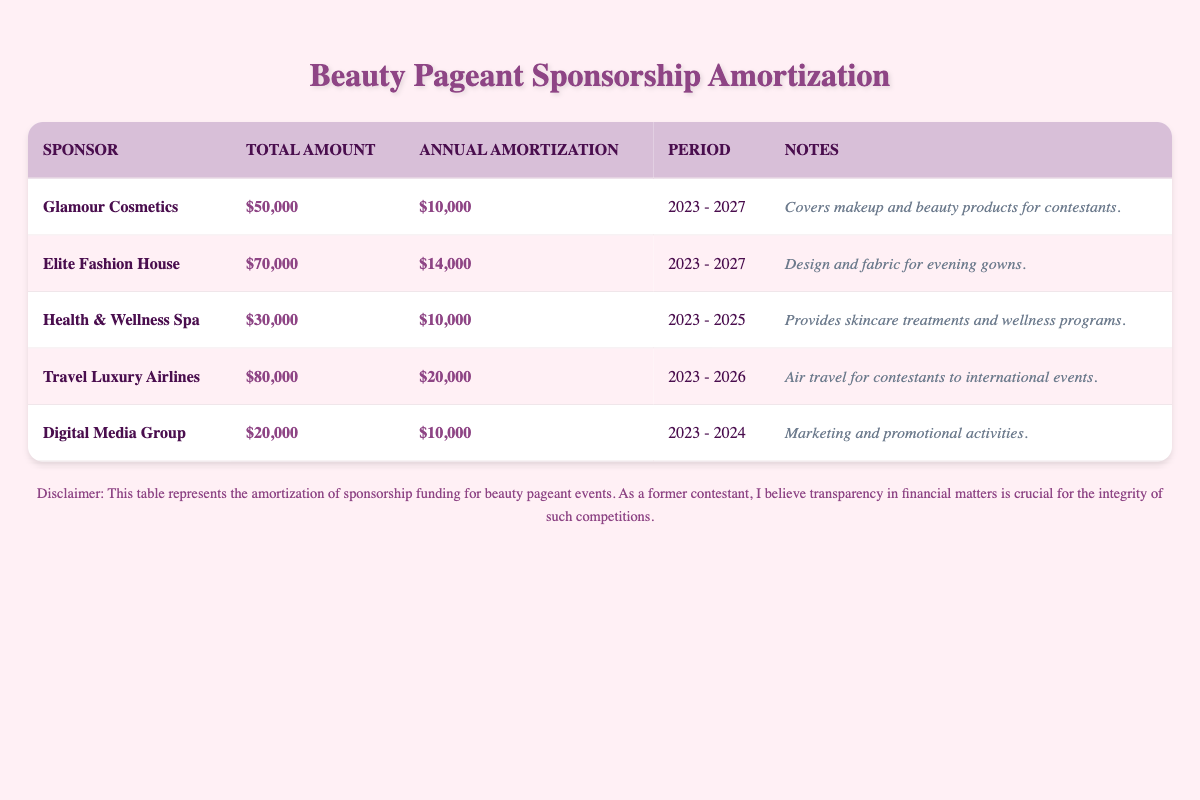What is the total sponsorship amount from Glamour Cosmetics? The table specifically states that Glamour Cosmetics has a sponsorship amount of $50,000.
Answer: $50,000 Which sponsor has the highest annual amortization amount? By comparing the annual amortization amounts listed in the table, Travel Luxury Airlines at $20,000 has the highest value.
Answer: Travel Luxury Airlines What is the total of the annual amortization amounts for all sponsors? The annual amortization amounts are $10,000 (Glamour), $14,000 (Elite), $10,000 (Health), $20,000 (Travel), and $10,000 (Digital). Adding these together: 10,000 + 14,000 + 10,000 + 20,000 + 10,000 = 64,000.
Answer: $64,000 Does the Health & Wellness Spa cover sponsorship funding for 5 years? The table notes that the Health & Wellness Spa has an amortization period of 3 years, from 2023 to 2025, which does not cover 5 years.
Answer: No Which sponsor aims to cover travel expenses for international events? The table indicates that Travel Luxury Airlines provides air travel for contestants to international events, making them the sponsor for travel expenses.
Answer: Travel Luxury Airlines What is the average annual amortization amount for all sponsors? The sum of the annual amortization amounts is $64,000 as calculated before. Since there are 5 sponsors, the average is 64,000 divided by 5, which is $12,800.
Answer: $12,800 Which sponsors are offering their support until the end of 2026? Both Glamour Cosmetics and Travel Luxury Airlines have amortization periods that extend to 2027 and 2026, respectively, thus they are the sponsors supporting till 2026 or beyond.
Answer: Glamour Cosmetics, Travel Luxury Airlines Is the sponsorship amount from Digital Media Group higher than $25,000? The table confirms the sponsorship amount for Digital Media Group is $20,000, which is lower than $25,000.
Answer: No 